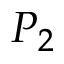<formula> <loc_0><loc_0><loc_500><loc_500>P _ { 2 }</formula> 